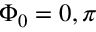<formula> <loc_0><loc_0><loc_500><loc_500>\Phi _ { 0 } = 0 , \pi</formula> 